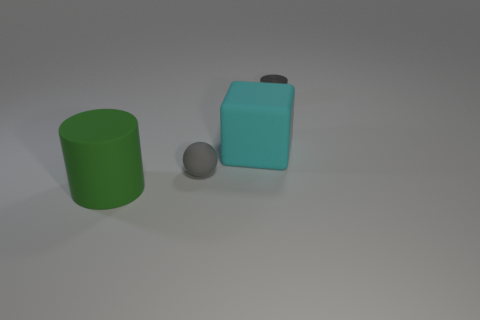There is another large thing that is made of the same material as the green thing; what is its color? cyan 